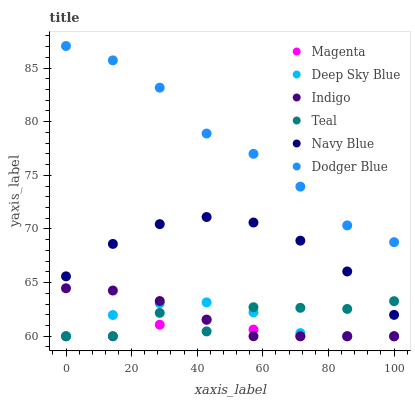Does Magenta have the minimum area under the curve?
Answer yes or no. Yes. Does Dodger Blue have the maximum area under the curve?
Answer yes or no. Yes. Does Deep Sky Blue have the minimum area under the curve?
Answer yes or no. No. Does Deep Sky Blue have the maximum area under the curve?
Answer yes or no. No. Is Indigo the smoothest?
Answer yes or no. Yes. Is Teal the roughest?
Answer yes or no. Yes. Is Deep Sky Blue the smoothest?
Answer yes or no. No. Is Deep Sky Blue the roughest?
Answer yes or no. No. Does Indigo have the lowest value?
Answer yes or no. Yes. Does Navy Blue have the lowest value?
Answer yes or no. No. Does Dodger Blue have the highest value?
Answer yes or no. Yes. Does Deep Sky Blue have the highest value?
Answer yes or no. No. Is Magenta less than Dodger Blue?
Answer yes or no. Yes. Is Dodger Blue greater than Magenta?
Answer yes or no. Yes. Does Indigo intersect Magenta?
Answer yes or no. Yes. Is Indigo less than Magenta?
Answer yes or no. No. Is Indigo greater than Magenta?
Answer yes or no. No. Does Magenta intersect Dodger Blue?
Answer yes or no. No. 